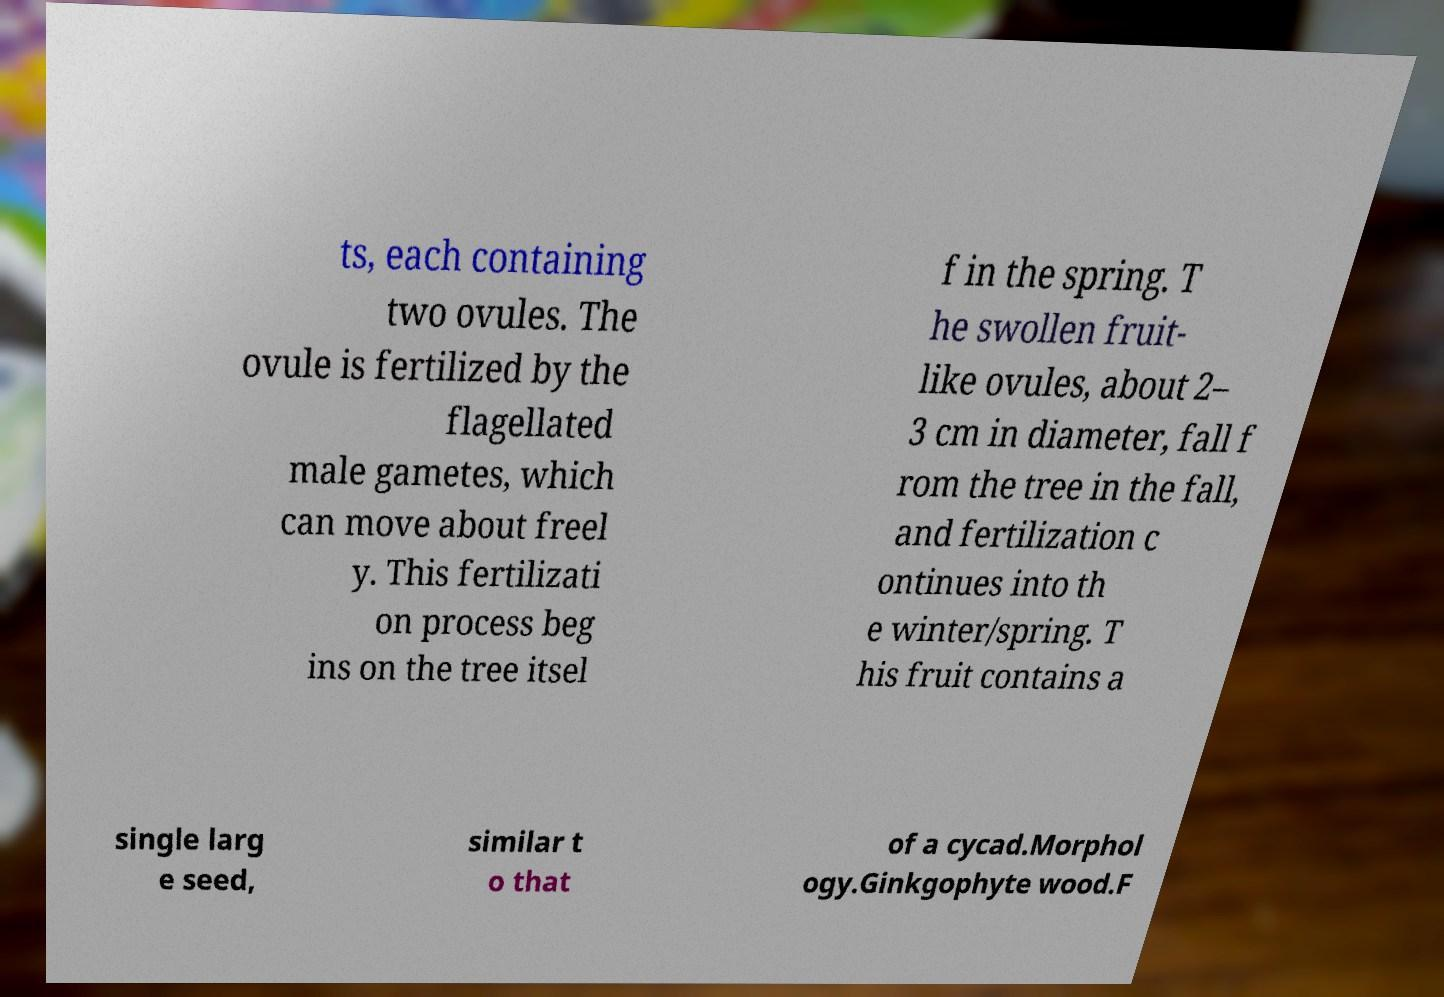What messages or text are displayed in this image? I need them in a readable, typed format. ts, each containing two ovules. The ovule is fertilized by the flagellated male gametes, which can move about freel y. This fertilizati on process beg ins on the tree itsel f in the spring. T he swollen fruit- like ovules, about 2– 3 cm in diameter, fall f rom the tree in the fall, and fertilization c ontinues into th e winter/spring. T his fruit contains a single larg e seed, similar t o that of a cycad.Morphol ogy.Ginkgophyte wood.F 